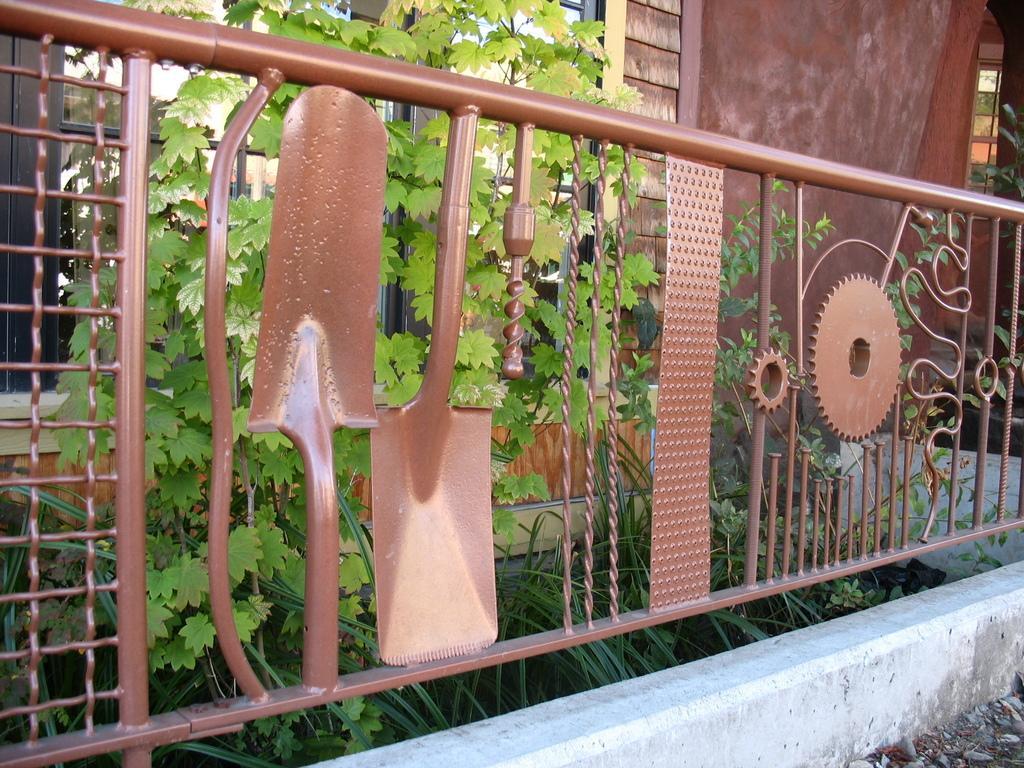What is the color of the railing in the image? The railing in the image has a brown color. What can be seen behind the railing? There are plants behind the railing. Is there any additional structure near the railing? Yes, there is a small side wall near the railing. What is visible in the background of the image? There is a wall in the background of the image. Can you hear any songs being played by the snake in the image? There is no snake or songs present in the image. 